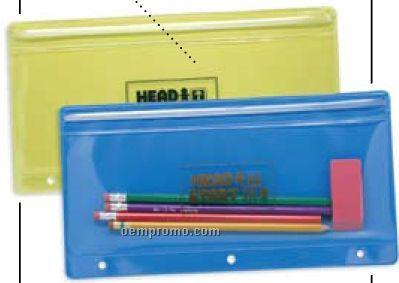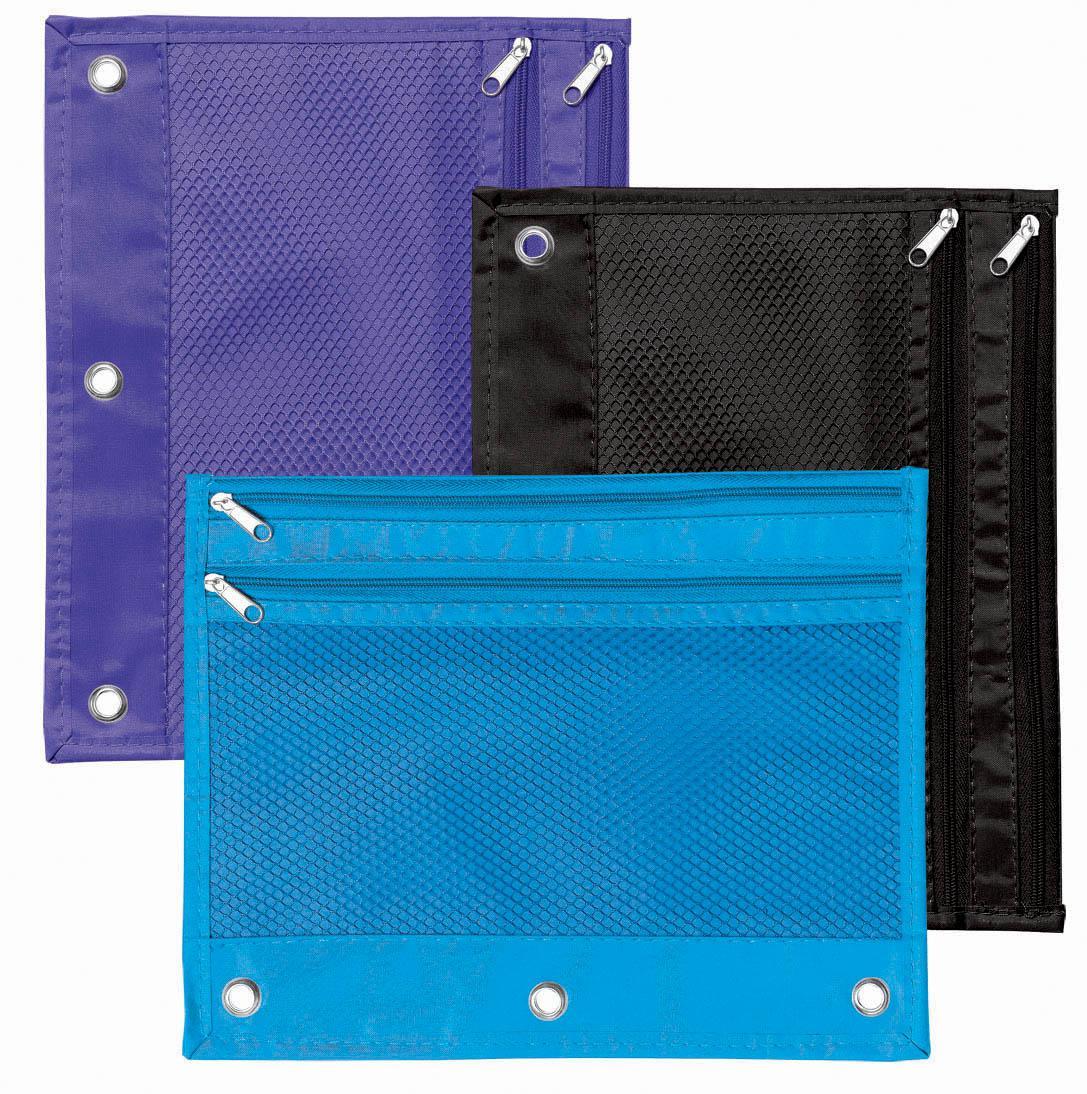The first image is the image on the left, the second image is the image on the right. Analyze the images presented: Is the assertion "An image shows at least five different solid-colored pencil cases with eyelets on one edge." valid? Answer yes or no. No. The first image is the image on the left, the second image is the image on the right. Given the left and right images, does the statement "There are three pencil cases in the right image." hold true? Answer yes or no. Yes. 